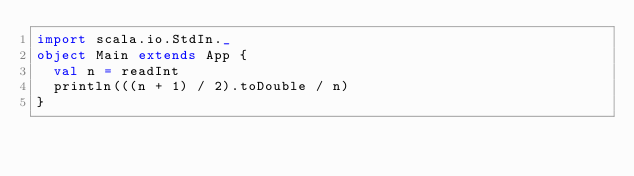Convert code to text. <code><loc_0><loc_0><loc_500><loc_500><_Scala_>import scala.io.StdIn._
object Main extends App {
  val n = readInt
  println(((n + 1) / 2).toDouble / n)
}
</code> 